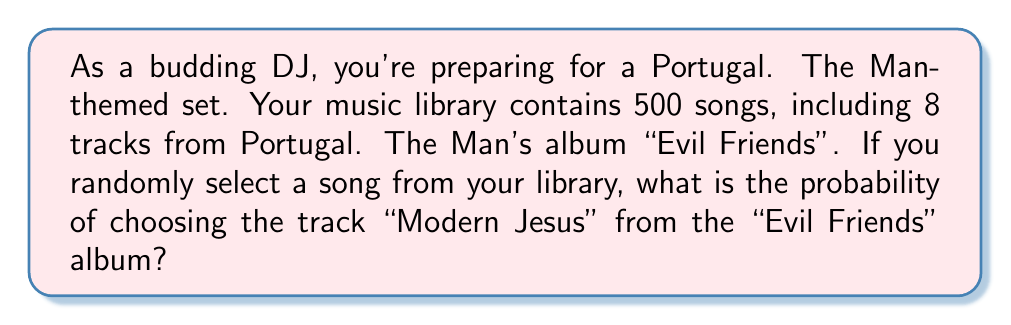Give your solution to this math problem. Let's approach this step-by-step:

1) First, we need to identify the total number of possible outcomes and the number of favorable outcomes:
   - Total number of songs in the library: 500
   - Number of times "Modern Jesus" appears in the library: 1 (assuming it's only on one album)

2) The probability of an event is calculated by dividing the number of favorable outcomes by the total number of possible outcomes:

   $$P(\text{event}) = \frac{\text{number of favorable outcomes}}{\text{total number of possible outcomes}}$$

3) In this case:
   $$P(\text{selecting "Modern Jesus"}) = \frac{1}{500}$$

4) To simplify this fraction:
   $$\frac{1}{500} = \frac{1}{5 \times 100} = \frac{1}{5 \times 10^2} = 0.002$$

5) We can also express this as a percentage:
   $$0.002 \times 100\% = 0.2\%$$

Therefore, the probability of randomly selecting "Modern Jesus" from your music library is 0.002 or 0.2%.
Answer: $\frac{1}{500}$ or $0.002$ or $0.2\%$ 